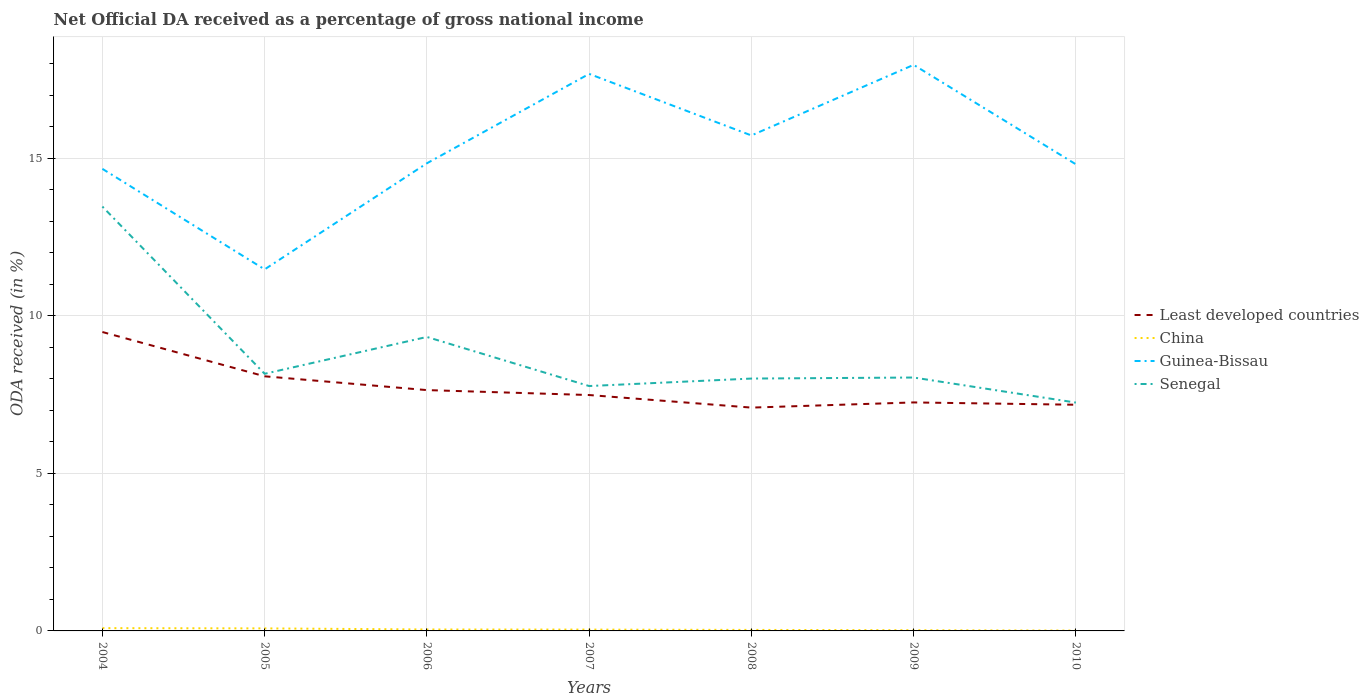Does the line corresponding to Senegal intersect with the line corresponding to Least developed countries?
Offer a very short reply. No. Is the number of lines equal to the number of legend labels?
Keep it short and to the point. Yes. Across all years, what is the maximum net official DA received in Least developed countries?
Make the answer very short. 7.09. What is the total net official DA received in Least developed countries in the graph?
Keep it short and to the point. 2. What is the difference between the highest and the second highest net official DA received in Senegal?
Offer a terse response. 6.22. What is the difference between two consecutive major ticks on the Y-axis?
Your answer should be very brief. 5. Does the graph contain grids?
Your answer should be compact. Yes. How many legend labels are there?
Ensure brevity in your answer.  4. How are the legend labels stacked?
Provide a succinct answer. Vertical. What is the title of the graph?
Provide a succinct answer. Net Official DA received as a percentage of gross national income. What is the label or title of the Y-axis?
Make the answer very short. ODA received (in %). What is the ODA received (in %) in Least developed countries in 2004?
Your answer should be compact. 9.49. What is the ODA received (in %) in China in 2004?
Give a very brief answer. 0.09. What is the ODA received (in %) in Guinea-Bissau in 2004?
Provide a short and direct response. 14.67. What is the ODA received (in %) of Senegal in 2004?
Provide a short and direct response. 13.47. What is the ODA received (in %) of Least developed countries in 2005?
Keep it short and to the point. 8.08. What is the ODA received (in %) in China in 2005?
Make the answer very short. 0.08. What is the ODA received (in %) of Guinea-Bissau in 2005?
Your answer should be compact. 11.48. What is the ODA received (in %) of Senegal in 2005?
Offer a very short reply. 8.16. What is the ODA received (in %) in Least developed countries in 2006?
Offer a very short reply. 7.64. What is the ODA received (in %) of China in 2006?
Provide a succinct answer. 0.05. What is the ODA received (in %) of Guinea-Bissau in 2006?
Ensure brevity in your answer.  14.84. What is the ODA received (in %) in Senegal in 2006?
Give a very brief answer. 9.33. What is the ODA received (in %) of Least developed countries in 2007?
Give a very brief answer. 7.49. What is the ODA received (in %) of China in 2007?
Provide a short and direct response. 0.04. What is the ODA received (in %) of Guinea-Bissau in 2007?
Your answer should be very brief. 17.68. What is the ODA received (in %) in Senegal in 2007?
Your answer should be compact. 7.77. What is the ODA received (in %) of Least developed countries in 2008?
Your answer should be compact. 7.09. What is the ODA received (in %) in China in 2008?
Your answer should be very brief. 0.03. What is the ODA received (in %) of Guinea-Bissau in 2008?
Your response must be concise. 15.73. What is the ODA received (in %) of Senegal in 2008?
Your answer should be compact. 8.01. What is the ODA received (in %) in Least developed countries in 2009?
Provide a succinct answer. 7.25. What is the ODA received (in %) in China in 2009?
Your answer should be very brief. 0.02. What is the ODA received (in %) in Guinea-Bissau in 2009?
Provide a succinct answer. 17.97. What is the ODA received (in %) of Senegal in 2009?
Provide a short and direct response. 8.04. What is the ODA received (in %) of Least developed countries in 2010?
Offer a terse response. 7.18. What is the ODA received (in %) of China in 2010?
Provide a succinct answer. 0.01. What is the ODA received (in %) in Guinea-Bissau in 2010?
Give a very brief answer. 14.81. What is the ODA received (in %) of Senegal in 2010?
Your answer should be very brief. 7.25. Across all years, what is the maximum ODA received (in %) of Least developed countries?
Make the answer very short. 9.49. Across all years, what is the maximum ODA received (in %) in China?
Your answer should be very brief. 0.09. Across all years, what is the maximum ODA received (in %) of Guinea-Bissau?
Make the answer very short. 17.97. Across all years, what is the maximum ODA received (in %) of Senegal?
Give a very brief answer. 13.47. Across all years, what is the minimum ODA received (in %) in Least developed countries?
Provide a short and direct response. 7.09. Across all years, what is the minimum ODA received (in %) in China?
Your response must be concise. 0.01. Across all years, what is the minimum ODA received (in %) in Guinea-Bissau?
Keep it short and to the point. 11.48. Across all years, what is the minimum ODA received (in %) in Senegal?
Your answer should be very brief. 7.25. What is the total ODA received (in %) in Least developed countries in the graph?
Your response must be concise. 54.22. What is the total ODA received (in %) in China in the graph?
Your answer should be compact. 0.32. What is the total ODA received (in %) in Guinea-Bissau in the graph?
Your answer should be compact. 107.18. What is the total ODA received (in %) in Senegal in the graph?
Provide a short and direct response. 62.04. What is the difference between the ODA received (in %) in Least developed countries in 2004 and that in 2005?
Keep it short and to the point. 1.41. What is the difference between the ODA received (in %) of China in 2004 and that in 2005?
Your response must be concise. 0.01. What is the difference between the ODA received (in %) of Guinea-Bissau in 2004 and that in 2005?
Keep it short and to the point. 3.19. What is the difference between the ODA received (in %) of Senegal in 2004 and that in 2005?
Your answer should be compact. 5.31. What is the difference between the ODA received (in %) in Least developed countries in 2004 and that in 2006?
Provide a succinct answer. 1.84. What is the difference between the ODA received (in %) in China in 2004 and that in 2006?
Offer a terse response. 0.04. What is the difference between the ODA received (in %) in Guinea-Bissau in 2004 and that in 2006?
Your answer should be very brief. -0.18. What is the difference between the ODA received (in %) in Senegal in 2004 and that in 2006?
Make the answer very short. 4.14. What is the difference between the ODA received (in %) in Least developed countries in 2004 and that in 2007?
Ensure brevity in your answer.  2. What is the difference between the ODA received (in %) in China in 2004 and that in 2007?
Your answer should be very brief. 0.05. What is the difference between the ODA received (in %) of Guinea-Bissau in 2004 and that in 2007?
Your answer should be compact. -3.01. What is the difference between the ODA received (in %) of Senegal in 2004 and that in 2007?
Your answer should be very brief. 5.7. What is the difference between the ODA received (in %) of Least developed countries in 2004 and that in 2008?
Your response must be concise. 2.4. What is the difference between the ODA received (in %) in China in 2004 and that in 2008?
Your response must be concise. 0.06. What is the difference between the ODA received (in %) in Guinea-Bissau in 2004 and that in 2008?
Give a very brief answer. -1.06. What is the difference between the ODA received (in %) in Senegal in 2004 and that in 2008?
Make the answer very short. 5.46. What is the difference between the ODA received (in %) of Least developed countries in 2004 and that in 2009?
Keep it short and to the point. 2.24. What is the difference between the ODA received (in %) of China in 2004 and that in 2009?
Your answer should be compact. 0.07. What is the difference between the ODA received (in %) of Guinea-Bissau in 2004 and that in 2009?
Provide a short and direct response. -3.3. What is the difference between the ODA received (in %) in Senegal in 2004 and that in 2009?
Provide a succinct answer. 5.43. What is the difference between the ODA received (in %) of Least developed countries in 2004 and that in 2010?
Provide a succinct answer. 2.31. What is the difference between the ODA received (in %) of China in 2004 and that in 2010?
Keep it short and to the point. 0.08. What is the difference between the ODA received (in %) in Guinea-Bissau in 2004 and that in 2010?
Your answer should be compact. -0.14. What is the difference between the ODA received (in %) of Senegal in 2004 and that in 2010?
Ensure brevity in your answer.  6.22. What is the difference between the ODA received (in %) in Least developed countries in 2005 and that in 2006?
Your answer should be very brief. 0.44. What is the difference between the ODA received (in %) in China in 2005 and that in 2006?
Provide a succinct answer. 0.03. What is the difference between the ODA received (in %) in Guinea-Bissau in 2005 and that in 2006?
Provide a short and direct response. -3.37. What is the difference between the ODA received (in %) in Senegal in 2005 and that in 2006?
Keep it short and to the point. -1.17. What is the difference between the ODA received (in %) in Least developed countries in 2005 and that in 2007?
Keep it short and to the point. 0.59. What is the difference between the ODA received (in %) in China in 2005 and that in 2007?
Provide a succinct answer. 0.04. What is the difference between the ODA received (in %) of Guinea-Bissau in 2005 and that in 2007?
Your response must be concise. -6.21. What is the difference between the ODA received (in %) in Senegal in 2005 and that in 2007?
Your answer should be very brief. 0.39. What is the difference between the ODA received (in %) in Least developed countries in 2005 and that in 2008?
Provide a short and direct response. 0.99. What is the difference between the ODA received (in %) in China in 2005 and that in 2008?
Provide a succinct answer. 0.05. What is the difference between the ODA received (in %) in Guinea-Bissau in 2005 and that in 2008?
Ensure brevity in your answer.  -4.25. What is the difference between the ODA received (in %) of Senegal in 2005 and that in 2008?
Your answer should be compact. 0.15. What is the difference between the ODA received (in %) in Least developed countries in 2005 and that in 2009?
Ensure brevity in your answer.  0.83. What is the difference between the ODA received (in %) of China in 2005 and that in 2009?
Your answer should be very brief. 0.06. What is the difference between the ODA received (in %) in Guinea-Bissau in 2005 and that in 2009?
Offer a terse response. -6.49. What is the difference between the ODA received (in %) of Senegal in 2005 and that in 2009?
Your response must be concise. 0.12. What is the difference between the ODA received (in %) in Least developed countries in 2005 and that in 2010?
Keep it short and to the point. 0.9. What is the difference between the ODA received (in %) in China in 2005 and that in 2010?
Keep it short and to the point. 0.07. What is the difference between the ODA received (in %) in Guinea-Bissau in 2005 and that in 2010?
Ensure brevity in your answer.  -3.34. What is the difference between the ODA received (in %) in Senegal in 2005 and that in 2010?
Provide a short and direct response. 0.91. What is the difference between the ODA received (in %) in Least developed countries in 2006 and that in 2007?
Your response must be concise. 0.16. What is the difference between the ODA received (in %) in China in 2006 and that in 2007?
Your response must be concise. 0. What is the difference between the ODA received (in %) in Guinea-Bissau in 2006 and that in 2007?
Your answer should be very brief. -2.84. What is the difference between the ODA received (in %) in Senegal in 2006 and that in 2007?
Provide a short and direct response. 1.56. What is the difference between the ODA received (in %) in Least developed countries in 2006 and that in 2008?
Provide a short and direct response. 0.56. What is the difference between the ODA received (in %) in China in 2006 and that in 2008?
Offer a very short reply. 0.01. What is the difference between the ODA received (in %) of Guinea-Bissau in 2006 and that in 2008?
Provide a short and direct response. -0.88. What is the difference between the ODA received (in %) in Senegal in 2006 and that in 2008?
Provide a short and direct response. 1.32. What is the difference between the ODA received (in %) in Least developed countries in 2006 and that in 2009?
Offer a terse response. 0.39. What is the difference between the ODA received (in %) in China in 2006 and that in 2009?
Provide a short and direct response. 0.02. What is the difference between the ODA received (in %) in Guinea-Bissau in 2006 and that in 2009?
Your response must be concise. -3.12. What is the difference between the ODA received (in %) in Senegal in 2006 and that in 2009?
Provide a succinct answer. 1.29. What is the difference between the ODA received (in %) of Least developed countries in 2006 and that in 2010?
Make the answer very short. 0.47. What is the difference between the ODA received (in %) in China in 2006 and that in 2010?
Provide a short and direct response. 0.04. What is the difference between the ODA received (in %) of Guinea-Bissau in 2006 and that in 2010?
Your answer should be compact. 0.03. What is the difference between the ODA received (in %) of Senegal in 2006 and that in 2010?
Keep it short and to the point. 2.08. What is the difference between the ODA received (in %) of Least developed countries in 2007 and that in 2008?
Provide a succinct answer. 0.4. What is the difference between the ODA received (in %) in China in 2007 and that in 2008?
Your answer should be compact. 0.01. What is the difference between the ODA received (in %) in Guinea-Bissau in 2007 and that in 2008?
Offer a terse response. 1.95. What is the difference between the ODA received (in %) in Senegal in 2007 and that in 2008?
Give a very brief answer. -0.24. What is the difference between the ODA received (in %) in Least developed countries in 2007 and that in 2009?
Make the answer very short. 0.23. What is the difference between the ODA received (in %) of China in 2007 and that in 2009?
Your answer should be very brief. 0.02. What is the difference between the ODA received (in %) of Guinea-Bissau in 2007 and that in 2009?
Your response must be concise. -0.29. What is the difference between the ODA received (in %) in Senegal in 2007 and that in 2009?
Give a very brief answer. -0.27. What is the difference between the ODA received (in %) of Least developed countries in 2007 and that in 2010?
Give a very brief answer. 0.31. What is the difference between the ODA received (in %) of China in 2007 and that in 2010?
Provide a short and direct response. 0.03. What is the difference between the ODA received (in %) in Guinea-Bissau in 2007 and that in 2010?
Make the answer very short. 2.87. What is the difference between the ODA received (in %) of Senegal in 2007 and that in 2010?
Offer a terse response. 0.53. What is the difference between the ODA received (in %) in Least developed countries in 2008 and that in 2009?
Provide a succinct answer. -0.16. What is the difference between the ODA received (in %) of China in 2008 and that in 2009?
Offer a very short reply. 0.01. What is the difference between the ODA received (in %) in Guinea-Bissau in 2008 and that in 2009?
Your answer should be compact. -2.24. What is the difference between the ODA received (in %) of Senegal in 2008 and that in 2009?
Ensure brevity in your answer.  -0.03. What is the difference between the ODA received (in %) in Least developed countries in 2008 and that in 2010?
Ensure brevity in your answer.  -0.09. What is the difference between the ODA received (in %) of China in 2008 and that in 2010?
Give a very brief answer. 0.02. What is the difference between the ODA received (in %) in Guinea-Bissau in 2008 and that in 2010?
Make the answer very short. 0.92. What is the difference between the ODA received (in %) of Senegal in 2008 and that in 2010?
Provide a short and direct response. 0.76. What is the difference between the ODA received (in %) of Least developed countries in 2009 and that in 2010?
Provide a short and direct response. 0.07. What is the difference between the ODA received (in %) of China in 2009 and that in 2010?
Ensure brevity in your answer.  0.01. What is the difference between the ODA received (in %) in Guinea-Bissau in 2009 and that in 2010?
Your answer should be compact. 3.16. What is the difference between the ODA received (in %) of Senegal in 2009 and that in 2010?
Keep it short and to the point. 0.8. What is the difference between the ODA received (in %) in Least developed countries in 2004 and the ODA received (in %) in China in 2005?
Your response must be concise. 9.41. What is the difference between the ODA received (in %) in Least developed countries in 2004 and the ODA received (in %) in Guinea-Bissau in 2005?
Your answer should be very brief. -1.99. What is the difference between the ODA received (in %) in Least developed countries in 2004 and the ODA received (in %) in Senegal in 2005?
Ensure brevity in your answer.  1.33. What is the difference between the ODA received (in %) of China in 2004 and the ODA received (in %) of Guinea-Bissau in 2005?
Your answer should be compact. -11.39. What is the difference between the ODA received (in %) of China in 2004 and the ODA received (in %) of Senegal in 2005?
Make the answer very short. -8.07. What is the difference between the ODA received (in %) in Guinea-Bissau in 2004 and the ODA received (in %) in Senegal in 2005?
Offer a very short reply. 6.5. What is the difference between the ODA received (in %) in Least developed countries in 2004 and the ODA received (in %) in China in 2006?
Ensure brevity in your answer.  9.44. What is the difference between the ODA received (in %) of Least developed countries in 2004 and the ODA received (in %) of Guinea-Bissau in 2006?
Offer a terse response. -5.36. What is the difference between the ODA received (in %) of Least developed countries in 2004 and the ODA received (in %) of Senegal in 2006?
Offer a very short reply. 0.16. What is the difference between the ODA received (in %) in China in 2004 and the ODA received (in %) in Guinea-Bissau in 2006?
Offer a very short reply. -14.76. What is the difference between the ODA received (in %) of China in 2004 and the ODA received (in %) of Senegal in 2006?
Keep it short and to the point. -9.24. What is the difference between the ODA received (in %) of Guinea-Bissau in 2004 and the ODA received (in %) of Senegal in 2006?
Give a very brief answer. 5.34. What is the difference between the ODA received (in %) of Least developed countries in 2004 and the ODA received (in %) of China in 2007?
Your answer should be very brief. 9.45. What is the difference between the ODA received (in %) in Least developed countries in 2004 and the ODA received (in %) in Guinea-Bissau in 2007?
Offer a very short reply. -8.19. What is the difference between the ODA received (in %) of Least developed countries in 2004 and the ODA received (in %) of Senegal in 2007?
Your answer should be very brief. 1.72. What is the difference between the ODA received (in %) of China in 2004 and the ODA received (in %) of Guinea-Bissau in 2007?
Your answer should be very brief. -17.59. What is the difference between the ODA received (in %) in China in 2004 and the ODA received (in %) in Senegal in 2007?
Your answer should be very brief. -7.68. What is the difference between the ODA received (in %) in Guinea-Bissau in 2004 and the ODA received (in %) in Senegal in 2007?
Offer a very short reply. 6.89. What is the difference between the ODA received (in %) in Least developed countries in 2004 and the ODA received (in %) in China in 2008?
Ensure brevity in your answer.  9.46. What is the difference between the ODA received (in %) in Least developed countries in 2004 and the ODA received (in %) in Guinea-Bissau in 2008?
Offer a terse response. -6.24. What is the difference between the ODA received (in %) of Least developed countries in 2004 and the ODA received (in %) of Senegal in 2008?
Offer a very short reply. 1.48. What is the difference between the ODA received (in %) in China in 2004 and the ODA received (in %) in Guinea-Bissau in 2008?
Make the answer very short. -15.64. What is the difference between the ODA received (in %) of China in 2004 and the ODA received (in %) of Senegal in 2008?
Keep it short and to the point. -7.92. What is the difference between the ODA received (in %) of Guinea-Bissau in 2004 and the ODA received (in %) of Senegal in 2008?
Provide a short and direct response. 6.66. What is the difference between the ODA received (in %) of Least developed countries in 2004 and the ODA received (in %) of China in 2009?
Keep it short and to the point. 9.47. What is the difference between the ODA received (in %) of Least developed countries in 2004 and the ODA received (in %) of Guinea-Bissau in 2009?
Make the answer very short. -8.48. What is the difference between the ODA received (in %) of Least developed countries in 2004 and the ODA received (in %) of Senegal in 2009?
Your response must be concise. 1.44. What is the difference between the ODA received (in %) in China in 2004 and the ODA received (in %) in Guinea-Bissau in 2009?
Your response must be concise. -17.88. What is the difference between the ODA received (in %) in China in 2004 and the ODA received (in %) in Senegal in 2009?
Provide a short and direct response. -7.95. What is the difference between the ODA received (in %) of Guinea-Bissau in 2004 and the ODA received (in %) of Senegal in 2009?
Your response must be concise. 6.62. What is the difference between the ODA received (in %) of Least developed countries in 2004 and the ODA received (in %) of China in 2010?
Give a very brief answer. 9.48. What is the difference between the ODA received (in %) of Least developed countries in 2004 and the ODA received (in %) of Guinea-Bissau in 2010?
Make the answer very short. -5.32. What is the difference between the ODA received (in %) of Least developed countries in 2004 and the ODA received (in %) of Senegal in 2010?
Offer a very short reply. 2.24. What is the difference between the ODA received (in %) of China in 2004 and the ODA received (in %) of Guinea-Bissau in 2010?
Ensure brevity in your answer.  -14.72. What is the difference between the ODA received (in %) of China in 2004 and the ODA received (in %) of Senegal in 2010?
Your answer should be compact. -7.16. What is the difference between the ODA received (in %) in Guinea-Bissau in 2004 and the ODA received (in %) in Senegal in 2010?
Offer a terse response. 7.42. What is the difference between the ODA received (in %) of Least developed countries in 2005 and the ODA received (in %) of China in 2006?
Provide a succinct answer. 8.04. What is the difference between the ODA received (in %) in Least developed countries in 2005 and the ODA received (in %) in Guinea-Bissau in 2006?
Provide a succinct answer. -6.76. What is the difference between the ODA received (in %) in Least developed countries in 2005 and the ODA received (in %) in Senegal in 2006?
Provide a succinct answer. -1.25. What is the difference between the ODA received (in %) in China in 2005 and the ODA received (in %) in Guinea-Bissau in 2006?
Offer a very short reply. -14.76. What is the difference between the ODA received (in %) in China in 2005 and the ODA received (in %) in Senegal in 2006?
Make the answer very short. -9.25. What is the difference between the ODA received (in %) of Guinea-Bissau in 2005 and the ODA received (in %) of Senegal in 2006?
Make the answer very short. 2.15. What is the difference between the ODA received (in %) in Least developed countries in 2005 and the ODA received (in %) in China in 2007?
Provide a succinct answer. 8.04. What is the difference between the ODA received (in %) in Least developed countries in 2005 and the ODA received (in %) in Guinea-Bissau in 2007?
Ensure brevity in your answer.  -9.6. What is the difference between the ODA received (in %) in Least developed countries in 2005 and the ODA received (in %) in Senegal in 2007?
Your answer should be compact. 0.31. What is the difference between the ODA received (in %) in China in 2005 and the ODA received (in %) in Guinea-Bissau in 2007?
Your answer should be very brief. -17.6. What is the difference between the ODA received (in %) of China in 2005 and the ODA received (in %) of Senegal in 2007?
Your answer should be compact. -7.69. What is the difference between the ODA received (in %) in Guinea-Bissau in 2005 and the ODA received (in %) in Senegal in 2007?
Ensure brevity in your answer.  3.7. What is the difference between the ODA received (in %) of Least developed countries in 2005 and the ODA received (in %) of China in 2008?
Make the answer very short. 8.05. What is the difference between the ODA received (in %) in Least developed countries in 2005 and the ODA received (in %) in Guinea-Bissau in 2008?
Ensure brevity in your answer.  -7.65. What is the difference between the ODA received (in %) in Least developed countries in 2005 and the ODA received (in %) in Senegal in 2008?
Offer a terse response. 0.07. What is the difference between the ODA received (in %) of China in 2005 and the ODA received (in %) of Guinea-Bissau in 2008?
Provide a succinct answer. -15.65. What is the difference between the ODA received (in %) in China in 2005 and the ODA received (in %) in Senegal in 2008?
Ensure brevity in your answer.  -7.93. What is the difference between the ODA received (in %) of Guinea-Bissau in 2005 and the ODA received (in %) of Senegal in 2008?
Give a very brief answer. 3.47. What is the difference between the ODA received (in %) of Least developed countries in 2005 and the ODA received (in %) of China in 2009?
Your answer should be compact. 8.06. What is the difference between the ODA received (in %) in Least developed countries in 2005 and the ODA received (in %) in Guinea-Bissau in 2009?
Offer a very short reply. -9.89. What is the difference between the ODA received (in %) in Least developed countries in 2005 and the ODA received (in %) in Senegal in 2009?
Keep it short and to the point. 0.04. What is the difference between the ODA received (in %) of China in 2005 and the ODA received (in %) of Guinea-Bissau in 2009?
Your response must be concise. -17.89. What is the difference between the ODA received (in %) in China in 2005 and the ODA received (in %) in Senegal in 2009?
Your response must be concise. -7.96. What is the difference between the ODA received (in %) of Guinea-Bissau in 2005 and the ODA received (in %) of Senegal in 2009?
Make the answer very short. 3.43. What is the difference between the ODA received (in %) in Least developed countries in 2005 and the ODA received (in %) in China in 2010?
Give a very brief answer. 8.07. What is the difference between the ODA received (in %) of Least developed countries in 2005 and the ODA received (in %) of Guinea-Bissau in 2010?
Provide a short and direct response. -6.73. What is the difference between the ODA received (in %) in Least developed countries in 2005 and the ODA received (in %) in Senegal in 2010?
Your answer should be very brief. 0.83. What is the difference between the ODA received (in %) of China in 2005 and the ODA received (in %) of Guinea-Bissau in 2010?
Ensure brevity in your answer.  -14.73. What is the difference between the ODA received (in %) in China in 2005 and the ODA received (in %) in Senegal in 2010?
Provide a short and direct response. -7.17. What is the difference between the ODA received (in %) of Guinea-Bissau in 2005 and the ODA received (in %) of Senegal in 2010?
Offer a terse response. 4.23. What is the difference between the ODA received (in %) in Least developed countries in 2006 and the ODA received (in %) in China in 2007?
Your response must be concise. 7.6. What is the difference between the ODA received (in %) in Least developed countries in 2006 and the ODA received (in %) in Guinea-Bissau in 2007?
Your answer should be very brief. -10.04. What is the difference between the ODA received (in %) of Least developed countries in 2006 and the ODA received (in %) of Senegal in 2007?
Ensure brevity in your answer.  -0.13. What is the difference between the ODA received (in %) in China in 2006 and the ODA received (in %) in Guinea-Bissau in 2007?
Your response must be concise. -17.64. What is the difference between the ODA received (in %) of China in 2006 and the ODA received (in %) of Senegal in 2007?
Your answer should be compact. -7.73. What is the difference between the ODA received (in %) of Guinea-Bissau in 2006 and the ODA received (in %) of Senegal in 2007?
Your answer should be compact. 7.07. What is the difference between the ODA received (in %) of Least developed countries in 2006 and the ODA received (in %) of China in 2008?
Offer a terse response. 7.61. What is the difference between the ODA received (in %) in Least developed countries in 2006 and the ODA received (in %) in Guinea-Bissau in 2008?
Give a very brief answer. -8.08. What is the difference between the ODA received (in %) of Least developed countries in 2006 and the ODA received (in %) of Senegal in 2008?
Your answer should be very brief. -0.37. What is the difference between the ODA received (in %) in China in 2006 and the ODA received (in %) in Guinea-Bissau in 2008?
Keep it short and to the point. -15.68. What is the difference between the ODA received (in %) of China in 2006 and the ODA received (in %) of Senegal in 2008?
Keep it short and to the point. -7.96. What is the difference between the ODA received (in %) in Guinea-Bissau in 2006 and the ODA received (in %) in Senegal in 2008?
Your response must be concise. 6.83. What is the difference between the ODA received (in %) in Least developed countries in 2006 and the ODA received (in %) in China in 2009?
Keep it short and to the point. 7.62. What is the difference between the ODA received (in %) in Least developed countries in 2006 and the ODA received (in %) in Guinea-Bissau in 2009?
Your answer should be very brief. -10.32. What is the difference between the ODA received (in %) in Least developed countries in 2006 and the ODA received (in %) in Senegal in 2009?
Ensure brevity in your answer.  -0.4. What is the difference between the ODA received (in %) in China in 2006 and the ODA received (in %) in Guinea-Bissau in 2009?
Give a very brief answer. -17.92. What is the difference between the ODA received (in %) of China in 2006 and the ODA received (in %) of Senegal in 2009?
Keep it short and to the point. -8. What is the difference between the ODA received (in %) of Guinea-Bissau in 2006 and the ODA received (in %) of Senegal in 2009?
Offer a very short reply. 6.8. What is the difference between the ODA received (in %) of Least developed countries in 2006 and the ODA received (in %) of China in 2010?
Offer a very short reply. 7.63. What is the difference between the ODA received (in %) of Least developed countries in 2006 and the ODA received (in %) of Guinea-Bissau in 2010?
Keep it short and to the point. -7.17. What is the difference between the ODA received (in %) of Least developed countries in 2006 and the ODA received (in %) of Senegal in 2010?
Your answer should be compact. 0.4. What is the difference between the ODA received (in %) of China in 2006 and the ODA received (in %) of Guinea-Bissau in 2010?
Your response must be concise. -14.77. What is the difference between the ODA received (in %) of China in 2006 and the ODA received (in %) of Senegal in 2010?
Make the answer very short. -7.2. What is the difference between the ODA received (in %) of Guinea-Bissau in 2006 and the ODA received (in %) of Senegal in 2010?
Give a very brief answer. 7.6. What is the difference between the ODA received (in %) in Least developed countries in 2007 and the ODA received (in %) in China in 2008?
Keep it short and to the point. 7.46. What is the difference between the ODA received (in %) of Least developed countries in 2007 and the ODA received (in %) of Guinea-Bissau in 2008?
Offer a very short reply. -8.24. What is the difference between the ODA received (in %) of Least developed countries in 2007 and the ODA received (in %) of Senegal in 2008?
Offer a terse response. -0.52. What is the difference between the ODA received (in %) in China in 2007 and the ODA received (in %) in Guinea-Bissau in 2008?
Your response must be concise. -15.69. What is the difference between the ODA received (in %) of China in 2007 and the ODA received (in %) of Senegal in 2008?
Offer a terse response. -7.97. What is the difference between the ODA received (in %) in Guinea-Bissau in 2007 and the ODA received (in %) in Senegal in 2008?
Your answer should be very brief. 9.67. What is the difference between the ODA received (in %) in Least developed countries in 2007 and the ODA received (in %) in China in 2009?
Your answer should be compact. 7.47. What is the difference between the ODA received (in %) in Least developed countries in 2007 and the ODA received (in %) in Guinea-Bissau in 2009?
Provide a succinct answer. -10.48. What is the difference between the ODA received (in %) of Least developed countries in 2007 and the ODA received (in %) of Senegal in 2009?
Offer a terse response. -0.56. What is the difference between the ODA received (in %) of China in 2007 and the ODA received (in %) of Guinea-Bissau in 2009?
Provide a succinct answer. -17.93. What is the difference between the ODA received (in %) of China in 2007 and the ODA received (in %) of Senegal in 2009?
Make the answer very short. -8. What is the difference between the ODA received (in %) of Guinea-Bissau in 2007 and the ODA received (in %) of Senegal in 2009?
Give a very brief answer. 9.64. What is the difference between the ODA received (in %) in Least developed countries in 2007 and the ODA received (in %) in China in 2010?
Your answer should be very brief. 7.48. What is the difference between the ODA received (in %) of Least developed countries in 2007 and the ODA received (in %) of Guinea-Bissau in 2010?
Ensure brevity in your answer.  -7.32. What is the difference between the ODA received (in %) of Least developed countries in 2007 and the ODA received (in %) of Senegal in 2010?
Make the answer very short. 0.24. What is the difference between the ODA received (in %) in China in 2007 and the ODA received (in %) in Guinea-Bissau in 2010?
Give a very brief answer. -14.77. What is the difference between the ODA received (in %) in China in 2007 and the ODA received (in %) in Senegal in 2010?
Provide a short and direct response. -7.21. What is the difference between the ODA received (in %) of Guinea-Bissau in 2007 and the ODA received (in %) of Senegal in 2010?
Your response must be concise. 10.43. What is the difference between the ODA received (in %) in Least developed countries in 2008 and the ODA received (in %) in China in 2009?
Your answer should be very brief. 7.07. What is the difference between the ODA received (in %) in Least developed countries in 2008 and the ODA received (in %) in Guinea-Bissau in 2009?
Provide a succinct answer. -10.88. What is the difference between the ODA received (in %) in Least developed countries in 2008 and the ODA received (in %) in Senegal in 2009?
Provide a short and direct response. -0.95. What is the difference between the ODA received (in %) in China in 2008 and the ODA received (in %) in Guinea-Bissau in 2009?
Provide a short and direct response. -17.94. What is the difference between the ODA received (in %) in China in 2008 and the ODA received (in %) in Senegal in 2009?
Provide a succinct answer. -8.01. What is the difference between the ODA received (in %) in Guinea-Bissau in 2008 and the ODA received (in %) in Senegal in 2009?
Your answer should be compact. 7.68. What is the difference between the ODA received (in %) in Least developed countries in 2008 and the ODA received (in %) in China in 2010?
Provide a short and direct response. 7.08. What is the difference between the ODA received (in %) of Least developed countries in 2008 and the ODA received (in %) of Guinea-Bissau in 2010?
Make the answer very short. -7.72. What is the difference between the ODA received (in %) in Least developed countries in 2008 and the ODA received (in %) in Senegal in 2010?
Offer a very short reply. -0.16. What is the difference between the ODA received (in %) in China in 2008 and the ODA received (in %) in Guinea-Bissau in 2010?
Provide a short and direct response. -14.78. What is the difference between the ODA received (in %) in China in 2008 and the ODA received (in %) in Senegal in 2010?
Your answer should be very brief. -7.22. What is the difference between the ODA received (in %) in Guinea-Bissau in 2008 and the ODA received (in %) in Senegal in 2010?
Offer a very short reply. 8.48. What is the difference between the ODA received (in %) in Least developed countries in 2009 and the ODA received (in %) in China in 2010?
Ensure brevity in your answer.  7.24. What is the difference between the ODA received (in %) of Least developed countries in 2009 and the ODA received (in %) of Guinea-Bissau in 2010?
Offer a very short reply. -7.56. What is the difference between the ODA received (in %) of Least developed countries in 2009 and the ODA received (in %) of Senegal in 2010?
Give a very brief answer. 0. What is the difference between the ODA received (in %) of China in 2009 and the ODA received (in %) of Guinea-Bissau in 2010?
Ensure brevity in your answer.  -14.79. What is the difference between the ODA received (in %) of China in 2009 and the ODA received (in %) of Senegal in 2010?
Your response must be concise. -7.23. What is the difference between the ODA received (in %) in Guinea-Bissau in 2009 and the ODA received (in %) in Senegal in 2010?
Provide a succinct answer. 10.72. What is the average ODA received (in %) in Least developed countries per year?
Provide a short and direct response. 7.75. What is the average ODA received (in %) in China per year?
Provide a short and direct response. 0.05. What is the average ODA received (in %) in Guinea-Bissau per year?
Make the answer very short. 15.31. What is the average ODA received (in %) in Senegal per year?
Keep it short and to the point. 8.86. In the year 2004, what is the difference between the ODA received (in %) of Least developed countries and ODA received (in %) of China?
Your answer should be compact. 9.4. In the year 2004, what is the difference between the ODA received (in %) in Least developed countries and ODA received (in %) in Guinea-Bissau?
Provide a short and direct response. -5.18. In the year 2004, what is the difference between the ODA received (in %) in Least developed countries and ODA received (in %) in Senegal?
Ensure brevity in your answer.  -3.98. In the year 2004, what is the difference between the ODA received (in %) in China and ODA received (in %) in Guinea-Bissau?
Make the answer very short. -14.58. In the year 2004, what is the difference between the ODA received (in %) in China and ODA received (in %) in Senegal?
Provide a succinct answer. -13.38. In the year 2004, what is the difference between the ODA received (in %) in Guinea-Bissau and ODA received (in %) in Senegal?
Your answer should be compact. 1.2. In the year 2005, what is the difference between the ODA received (in %) in Least developed countries and ODA received (in %) in China?
Keep it short and to the point. 8. In the year 2005, what is the difference between the ODA received (in %) in Least developed countries and ODA received (in %) in Guinea-Bissau?
Provide a short and direct response. -3.39. In the year 2005, what is the difference between the ODA received (in %) of Least developed countries and ODA received (in %) of Senegal?
Provide a short and direct response. -0.08. In the year 2005, what is the difference between the ODA received (in %) of China and ODA received (in %) of Guinea-Bissau?
Keep it short and to the point. -11.4. In the year 2005, what is the difference between the ODA received (in %) in China and ODA received (in %) in Senegal?
Provide a succinct answer. -8.08. In the year 2005, what is the difference between the ODA received (in %) of Guinea-Bissau and ODA received (in %) of Senegal?
Your answer should be very brief. 3.31. In the year 2006, what is the difference between the ODA received (in %) in Least developed countries and ODA received (in %) in China?
Make the answer very short. 7.6. In the year 2006, what is the difference between the ODA received (in %) in Least developed countries and ODA received (in %) in Guinea-Bissau?
Make the answer very short. -7.2. In the year 2006, what is the difference between the ODA received (in %) of Least developed countries and ODA received (in %) of Senegal?
Give a very brief answer. -1.69. In the year 2006, what is the difference between the ODA received (in %) of China and ODA received (in %) of Guinea-Bissau?
Offer a terse response. -14.8. In the year 2006, what is the difference between the ODA received (in %) in China and ODA received (in %) in Senegal?
Keep it short and to the point. -9.29. In the year 2006, what is the difference between the ODA received (in %) of Guinea-Bissau and ODA received (in %) of Senegal?
Offer a terse response. 5.51. In the year 2007, what is the difference between the ODA received (in %) of Least developed countries and ODA received (in %) of China?
Offer a very short reply. 7.45. In the year 2007, what is the difference between the ODA received (in %) in Least developed countries and ODA received (in %) in Guinea-Bissau?
Give a very brief answer. -10.19. In the year 2007, what is the difference between the ODA received (in %) of Least developed countries and ODA received (in %) of Senegal?
Offer a terse response. -0.29. In the year 2007, what is the difference between the ODA received (in %) in China and ODA received (in %) in Guinea-Bissau?
Offer a very short reply. -17.64. In the year 2007, what is the difference between the ODA received (in %) in China and ODA received (in %) in Senegal?
Keep it short and to the point. -7.73. In the year 2007, what is the difference between the ODA received (in %) of Guinea-Bissau and ODA received (in %) of Senegal?
Your answer should be compact. 9.91. In the year 2008, what is the difference between the ODA received (in %) of Least developed countries and ODA received (in %) of China?
Keep it short and to the point. 7.06. In the year 2008, what is the difference between the ODA received (in %) of Least developed countries and ODA received (in %) of Guinea-Bissau?
Make the answer very short. -8.64. In the year 2008, what is the difference between the ODA received (in %) of Least developed countries and ODA received (in %) of Senegal?
Your answer should be very brief. -0.92. In the year 2008, what is the difference between the ODA received (in %) of China and ODA received (in %) of Guinea-Bissau?
Keep it short and to the point. -15.7. In the year 2008, what is the difference between the ODA received (in %) of China and ODA received (in %) of Senegal?
Keep it short and to the point. -7.98. In the year 2008, what is the difference between the ODA received (in %) in Guinea-Bissau and ODA received (in %) in Senegal?
Provide a short and direct response. 7.72. In the year 2009, what is the difference between the ODA received (in %) of Least developed countries and ODA received (in %) of China?
Ensure brevity in your answer.  7.23. In the year 2009, what is the difference between the ODA received (in %) of Least developed countries and ODA received (in %) of Guinea-Bissau?
Make the answer very short. -10.72. In the year 2009, what is the difference between the ODA received (in %) of Least developed countries and ODA received (in %) of Senegal?
Provide a succinct answer. -0.79. In the year 2009, what is the difference between the ODA received (in %) in China and ODA received (in %) in Guinea-Bissau?
Provide a succinct answer. -17.95. In the year 2009, what is the difference between the ODA received (in %) of China and ODA received (in %) of Senegal?
Your response must be concise. -8.02. In the year 2009, what is the difference between the ODA received (in %) in Guinea-Bissau and ODA received (in %) in Senegal?
Provide a short and direct response. 9.92. In the year 2010, what is the difference between the ODA received (in %) in Least developed countries and ODA received (in %) in China?
Offer a very short reply. 7.17. In the year 2010, what is the difference between the ODA received (in %) of Least developed countries and ODA received (in %) of Guinea-Bissau?
Make the answer very short. -7.63. In the year 2010, what is the difference between the ODA received (in %) of Least developed countries and ODA received (in %) of Senegal?
Offer a very short reply. -0.07. In the year 2010, what is the difference between the ODA received (in %) in China and ODA received (in %) in Guinea-Bissau?
Your answer should be very brief. -14.8. In the year 2010, what is the difference between the ODA received (in %) in China and ODA received (in %) in Senegal?
Offer a terse response. -7.24. In the year 2010, what is the difference between the ODA received (in %) of Guinea-Bissau and ODA received (in %) of Senegal?
Keep it short and to the point. 7.56. What is the ratio of the ODA received (in %) in Least developed countries in 2004 to that in 2005?
Ensure brevity in your answer.  1.17. What is the ratio of the ODA received (in %) of China in 2004 to that in 2005?
Offer a terse response. 1.1. What is the ratio of the ODA received (in %) in Guinea-Bissau in 2004 to that in 2005?
Your response must be concise. 1.28. What is the ratio of the ODA received (in %) in Senegal in 2004 to that in 2005?
Offer a very short reply. 1.65. What is the ratio of the ODA received (in %) in Least developed countries in 2004 to that in 2006?
Your answer should be very brief. 1.24. What is the ratio of the ODA received (in %) of China in 2004 to that in 2006?
Provide a short and direct response. 1.93. What is the ratio of the ODA received (in %) in Guinea-Bissau in 2004 to that in 2006?
Offer a very short reply. 0.99. What is the ratio of the ODA received (in %) in Senegal in 2004 to that in 2006?
Offer a very short reply. 1.44. What is the ratio of the ODA received (in %) of Least developed countries in 2004 to that in 2007?
Offer a terse response. 1.27. What is the ratio of the ODA received (in %) of China in 2004 to that in 2007?
Your response must be concise. 2.1. What is the ratio of the ODA received (in %) in Guinea-Bissau in 2004 to that in 2007?
Your answer should be very brief. 0.83. What is the ratio of the ODA received (in %) of Senegal in 2004 to that in 2007?
Give a very brief answer. 1.73. What is the ratio of the ODA received (in %) of Least developed countries in 2004 to that in 2008?
Provide a succinct answer. 1.34. What is the ratio of the ODA received (in %) of China in 2004 to that in 2008?
Keep it short and to the point. 2.75. What is the ratio of the ODA received (in %) in Guinea-Bissau in 2004 to that in 2008?
Provide a short and direct response. 0.93. What is the ratio of the ODA received (in %) of Senegal in 2004 to that in 2008?
Keep it short and to the point. 1.68. What is the ratio of the ODA received (in %) in Least developed countries in 2004 to that in 2009?
Provide a succinct answer. 1.31. What is the ratio of the ODA received (in %) in China in 2004 to that in 2009?
Your answer should be very brief. 3.96. What is the ratio of the ODA received (in %) in Guinea-Bissau in 2004 to that in 2009?
Your answer should be very brief. 0.82. What is the ratio of the ODA received (in %) of Senegal in 2004 to that in 2009?
Make the answer very short. 1.67. What is the ratio of the ODA received (in %) of Least developed countries in 2004 to that in 2010?
Your answer should be very brief. 1.32. What is the ratio of the ODA received (in %) of China in 2004 to that in 2010?
Your response must be concise. 8.25. What is the ratio of the ODA received (in %) in Guinea-Bissau in 2004 to that in 2010?
Your response must be concise. 0.99. What is the ratio of the ODA received (in %) of Senegal in 2004 to that in 2010?
Offer a terse response. 1.86. What is the ratio of the ODA received (in %) of Least developed countries in 2005 to that in 2006?
Ensure brevity in your answer.  1.06. What is the ratio of the ODA received (in %) in China in 2005 to that in 2006?
Give a very brief answer. 1.76. What is the ratio of the ODA received (in %) in Guinea-Bissau in 2005 to that in 2006?
Your answer should be compact. 0.77. What is the ratio of the ODA received (in %) of Senegal in 2005 to that in 2006?
Your response must be concise. 0.87. What is the ratio of the ODA received (in %) of Least developed countries in 2005 to that in 2007?
Ensure brevity in your answer.  1.08. What is the ratio of the ODA received (in %) of China in 2005 to that in 2007?
Your answer should be compact. 1.91. What is the ratio of the ODA received (in %) in Guinea-Bissau in 2005 to that in 2007?
Ensure brevity in your answer.  0.65. What is the ratio of the ODA received (in %) in Senegal in 2005 to that in 2007?
Your response must be concise. 1.05. What is the ratio of the ODA received (in %) in Least developed countries in 2005 to that in 2008?
Provide a succinct answer. 1.14. What is the ratio of the ODA received (in %) in China in 2005 to that in 2008?
Keep it short and to the point. 2.5. What is the ratio of the ODA received (in %) of Guinea-Bissau in 2005 to that in 2008?
Your response must be concise. 0.73. What is the ratio of the ODA received (in %) in Senegal in 2005 to that in 2008?
Offer a very short reply. 1.02. What is the ratio of the ODA received (in %) of Least developed countries in 2005 to that in 2009?
Provide a short and direct response. 1.11. What is the ratio of the ODA received (in %) in China in 2005 to that in 2009?
Provide a succinct answer. 3.6. What is the ratio of the ODA received (in %) in Guinea-Bissau in 2005 to that in 2009?
Give a very brief answer. 0.64. What is the ratio of the ODA received (in %) of Senegal in 2005 to that in 2009?
Give a very brief answer. 1.01. What is the ratio of the ODA received (in %) in Least developed countries in 2005 to that in 2010?
Your answer should be compact. 1.13. What is the ratio of the ODA received (in %) in China in 2005 to that in 2010?
Your answer should be compact. 7.5. What is the ratio of the ODA received (in %) of Guinea-Bissau in 2005 to that in 2010?
Offer a terse response. 0.77. What is the ratio of the ODA received (in %) of Senegal in 2005 to that in 2010?
Offer a very short reply. 1.13. What is the ratio of the ODA received (in %) of Least developed countries in 2006 to that in 2007?
Your answer should be very brief. 1.02. What is the ratio of the ODA received (in %) of China in 2006 to that in 2007?
Your answer should be very brief. 1.09. What is the ratio of the ODA received (in %) in Guinea-Bissau in 2006 to that in 2007?
Offer a terse response. 0.84. What is the ratio of the ODA received (in %) of Senegal in 2006 to that in 2007?
Keep it short and to the point. 1.2. What is the ratio of the ODA received (in %) of Least developed countries in 2006 to that in 2008?
Offer a very short reply. 1.08. What is the ratio of the ODA received (in %) in China in 2006 to that in 2008?
Your answer should be compact. 1.42. What is the ratio of the ODA received (in %) in Guinea-Bissau in 2006 to that in 2008?
Keep it short and to the point. 0.94. What is the ratio of the ODA received (in %) in Senegal in 2006 to that in 2008?
Provide a succinct answer. 1.16. What is the ratio of the ODA received (in %) in Least developed countries in 2006 to that in 2009?
Ensure brevity in your answer.  1.05. What is the ratio of the ODA received (in %) of China in 2006 to that in 2009?
Give a very brief answer. 2.05. What is the ratio of the ODA received (in %) of Guinea-Bissau in 2006 to that in 2009?
Ensure brevity in your answer.  0.83. What is the ratio of the ODA received (in %) in Senegal in 2006 to that in 2009?
Offer a very short reply. 1.16. What is the ratio of the ODA received (in %) in Least developed countries in 2006 to that in 2010?
Make the answer very short. 1.06. What is the ratio of the ODA received (in %) of China in 2006 to that in 2010?
Offer a very short reply. 4.26. What is the ratio of the ODA received (in %) in Senegal in 2006 to that in 2010?
Make the answer very short. 1.29. What is the ratio of the ODA received (in %) in Least developed countries in 2007 to that in 2008?
Make the answer very short. 1.06. What is the ratio of the ODA received (in %) in China in 2007 to that in 2008?
Give a very brief answer. 1.31. What is the ratio of the ODA received (in %) in Guinea-Bissau in 2007 to that in 2008?
Offer a terse response. 1.12. What is the ratio of the ODA received (in %) of Senegal in 2007 to that in 2008?
Offer a very short reply. 0.97. What is the ratio of the ODA received (in %) of Least developed countries in 2007 to that in 2009?
Your response must be concise. 1.03. What is the ratio of the ODA received (in %) of China in 2007 to that in 2009?
Your response must be concise. 1.88. What is the ratio of the ODA received (in %) of Guinea-Bissau in 2007 to that in 2009?
Give a very brief answer. 0.98. What is the ratio of the ODA received (in %) of Senegal in 2007 to that in 2009?
Your response must be concise. 0.97. What is the ratio of the ODA received (in %) in Least developed countries in 2007 to that in 2010?
Ensure brevity in your answer.  1.04. What is the ratio of the ODA received (in %) of China in 2007 to that in 2010?
Give a very brief answer. 3.92. What is the ratio of the ODA received (in %) in Guinea-Bissau in 2007 to that in 2010?
Keep it short and to the point. 1.19. What is the ratio of the ODA received (in %) of Senegal in 2007 to that in 2010?
Make the answer very short. 1.07. What is the ratio of the ODA received (in %) in Least developed countries in 2008 to that in 2009?
Your answer should be compact. 0.98. What is the ratio of the ODA received (in %) of China in 2008 to that in 2009?
Make the answer very short. 1.44. What is the ratio of the ODA received (in %) of Guinea-Bissau in 2008 to that in 2009?
Ensure brevity in your answer.  0.88. What is the ratio of the ODA received (in %) in Least developed countries in 2008 to that in 2010?
Give a very brief answer. 0.99. What is the ratio of the ODA received (in %) of China in 2008 to that in 2010?
Make the answer very short. 3. What is the ratio of the ODA received (in %) of Guinea-Bissau in 2008 to that in 2010?
Offer a terse response. 1.06. What is the ratio of the ODA received (in %) in Senegal in 2008 to that in 2010?
Your answer should be very brief. 1.11. What is the ratio of the ODA received (in %) in Least developed countries in 2009 to that in 2010?
Provide a succinct answer. 1.01. What is the ratio of the ODA received (in %) of China in 2009 to that in 2010?
Your answer should be compact. 2.08. What is the ratio of the ODA received (in %) in Guinea-Bissau in 2009 to that in 2010?
Offer a very short reply. 1.21. What is the ratio of the ODA received (in %) in Senegal in 2009 to that in 2010?
Provide a short and direct response. 1.11. What is the difference between the highest and the second highest ODA received (in %) in Least developed countries?
Ensure brevity in your answer.  1.41. What is the difference between the highest and the second highest ODA received (in %) of China?
Ensure brevity in your answer.  0.01. What is the difference between the highest and the second highest ODA received (in %) in Guinea-Bissau?
Offer a very short reply. 0.29. What is the difference between the highest and the second highest ODA received (in %) of Senegal?
Your answer should be very brief. 4.14. What is the difference between the highest and the lowest ODA received (in %) of Least developed countries?
Provide a succinct answer. 2.4. What is the difference between the highest and the lowest ODA received (in %) of China?
Offer a terse response. 0.08. What is the difference between the highest and the lowest ODA received (in %) of Guinea-Bissau?
Make the answer very short. 6.49. What is the difference between the highest and the lowest ODA received (in %) in Senegal?
Provide a short and direct response. 6.22. 